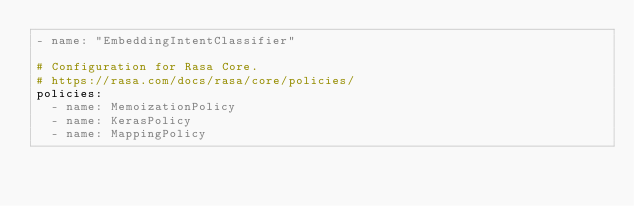<code> <loc_0><loc_0><loc_500><loc_500><_YAML_>- name: "EmbeddingIntentClassifier"

# Configuration for Rasa Core.
# https://rasa.com/docs/rasa/core/policies/
policies:
  - name: MemoizationPolicy
  - name: KerasPolicy
  - name: MappingPolicy
</code> 